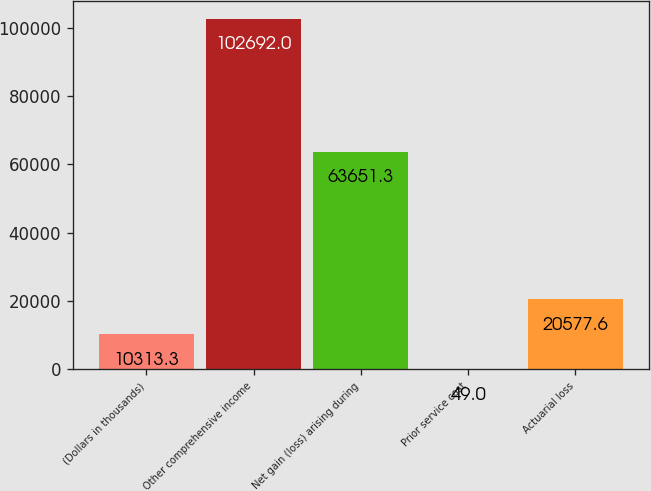Convert chart. <chart><loc_0><loc_0><loc_500><loc_500><bar_chart><fcel>(Dollars in thousands)<fcel>Other comprehensive income<fcel>Net gain (loss) arising during<fcel>Prior service cost<fcel>Actuarial loss<nl><fcel>10313.3<fcel>102692<fcel>63651.3<fcel>49<fcel>20577.6<nl></chart> 